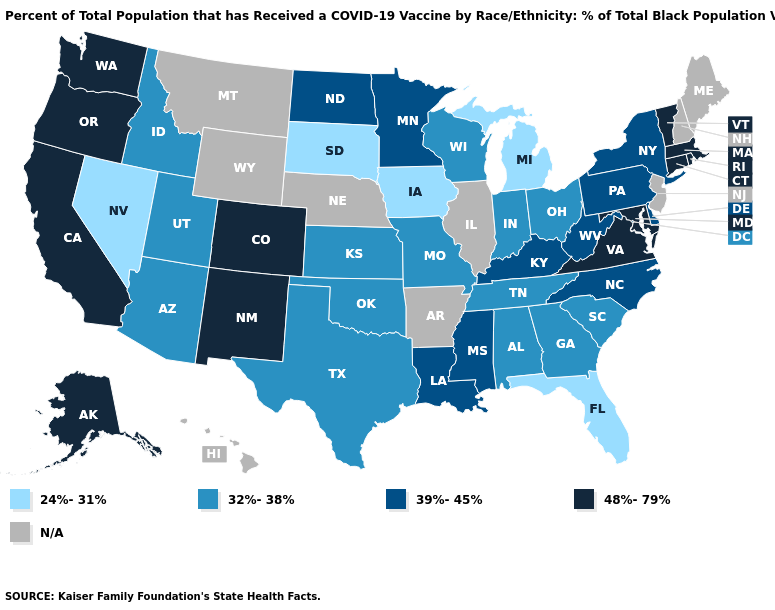What is the value of Florida?
Short answer required. 24%-31%. What is the value of West Virginia?
Give a very brief answer. 39%-45%. What is the value of New Mexico?
Short answer required. 48%-79%. Name the states that have a value in the range 39%-45%?
Quick response, please. Delaware, Kentucky, Louisiana, Minnesota, Mississippi, New York, North Carolina, North Dakota, Pennsylvania, West Virginia. Name the states that have a value in the range N/A?
Be succinct. Arkansas, Hawaii, Illinois, Maine, Montana, Nebraska, New Hampshire, New Jersey, Wyoming. Name the states that have a value in the range 24%-31%?
Give a very brief answer. Florida, Iowa, Michigan, Nevada, South Dakota. What is the lowest value in the West?
Concise answer only. 24%-31%. Does Washington have the highest value in the USA?
Keep it brief. Yes. Does Nevada have the lowest value in the West?
Quick response, please. Yes. Does the map have missing data?
Answer briefly. Yes. Which states have the lowest value in the USA?
Concise answer only. Florida, Iowa, Michigan, Nevada, South Dakota. What is the lowest value in the South?
Short answer required. 24%-31%. Name the states that have a value in the range 32%-38%?
Keep it brief. Alabama, Arizona, Georgia, Idaho, Indiana, Kansas, Missouri, Ohio, Oklahoma, South Carolina, Tennessee, Texas, Utah, Wisconsin. Name the states that have a value in the range 24%-31%?
Short answer required. Florida, Iowa, Michigan, Nevada, South Dakota. 